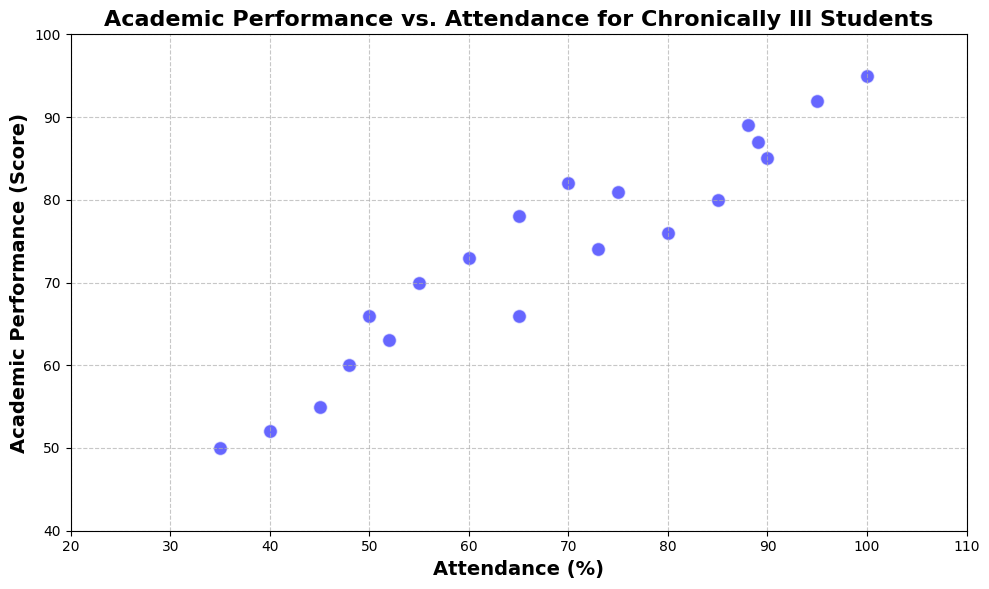What is the range of Academic Performance scores in the data? To determine the range, find the difference between the maximum and minimum scores. The maximum Academic Performance score is 95, and the minimum is 50. The range is 95 - 50.
Answer: 45 Is there a visible correlation between Attendance and Academic Performance? By looking at the scatter plot, observe the general pattern. The data points seem to form an upward trend, showing that higher Attendance usually correlates with higher Academic Performance.
Answer: Yes Which data point has the highest Attendance but does not have the highest Academic Performance? Find the data point with the highest Attendance, which is 100%. Check if its Academic Performance score is the highest. The score for this point is 95, which is not the highest in terms of Academic Performance alone.
Answer: The point with Attendance of 100% Identify the outliers, if any, in the scatter plot. Outliers are data points that deviate significantly from the other observations. By scanning the scatter plot, the data points seem well-distributed without any extreme outliers.
Answer: No outliers What is the average Academic Performance score for students with Attendance over 80%? List the points with Attendance values over 80% (85, 95, 88, 89, 85, 100). Their Academic Performance scores are (85, 92, 89, 87, 80, 95). To find the average: (85 + 92 + 89 + 87 + 80 + 95) / 6 = 528 / 6.
Answer: 88 Which student has the lowest Academic Performance score, and what is their Attendance percentage? Search for the lowest Academic Performance score on the plot, which is 50. The Attendance percentage for this student is 35%.
Answer: The student with Academic Performance of 50 and Attendance 35% How many students have both Academic Performance and Attendance scores above 80? Count the data points where both values are above 80. The points are (85, 90) and (95, 100).
Answer: 2 students Compare the Academic Performance scores of students with Attendance percentages of 65% and 75%. Which is higher? Identify the points with Attendance of 65% and 75%, whose Academic Performance scores are 78 and 81, respectively. Compare these two values.
Answer: 81 is higher What is the visual pattern observed for high Attendance percentages in the plot? Review the scatter plot and note the distribution pattern for high Attendance percentages (above 80%). These data points show a general trend of higher Academic Performance.
Answer: High Attendance correlates with high Academic Performance What is the median Attendance percentage in the data set? Rank the Attendance percentages and find the middle value. The sorted percentages (35, 40, 45, 48, 50, 52, 55, 60, 65, 65, 70, 73, 75, 80, 85, 88, 89, 90, 95, 100) give the median value as the average of the 10th and 11th values (65 and 70) divides by 2.
Answer: 67.5 